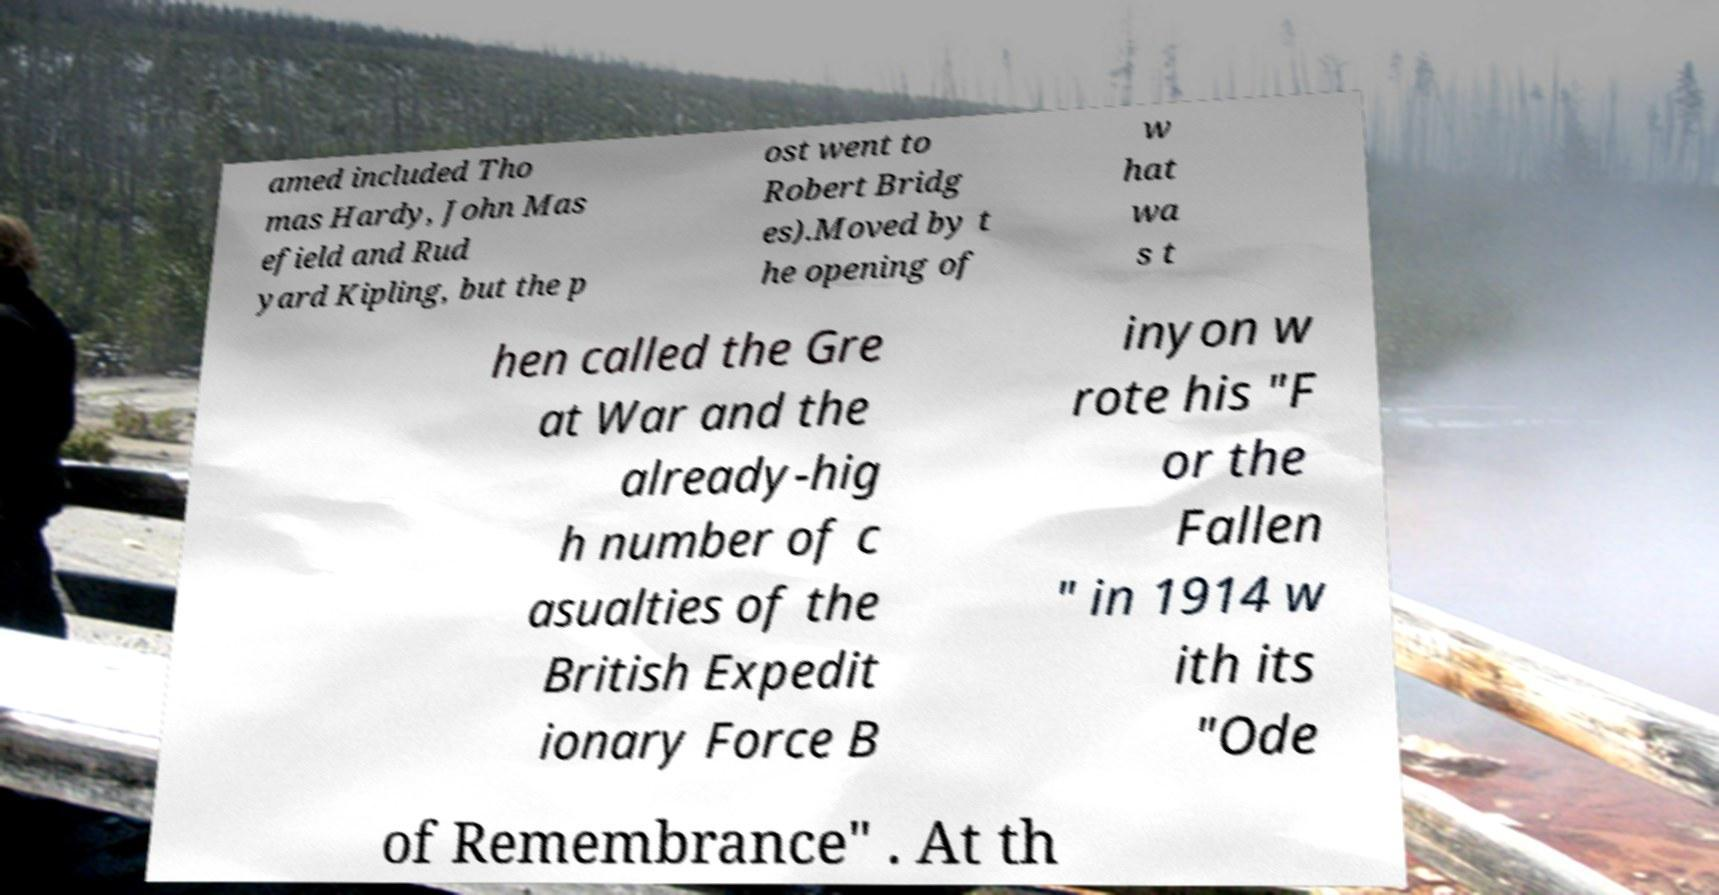Could you assist in decoding the text presented in this image and type it out clearly? amed included Tho mas Hardy, John Mas efield and Rud yard Kipling, but the p ost went to Robert Bridg es).Moved by t he opening of w hat wa s t hen called the Gre at War and the already-hig h number of c asualties of the British Expedit ionary Force B inyon w rote his "F or the Fallen " in 1914 w ith its "Ode of Remembrance" . At th 